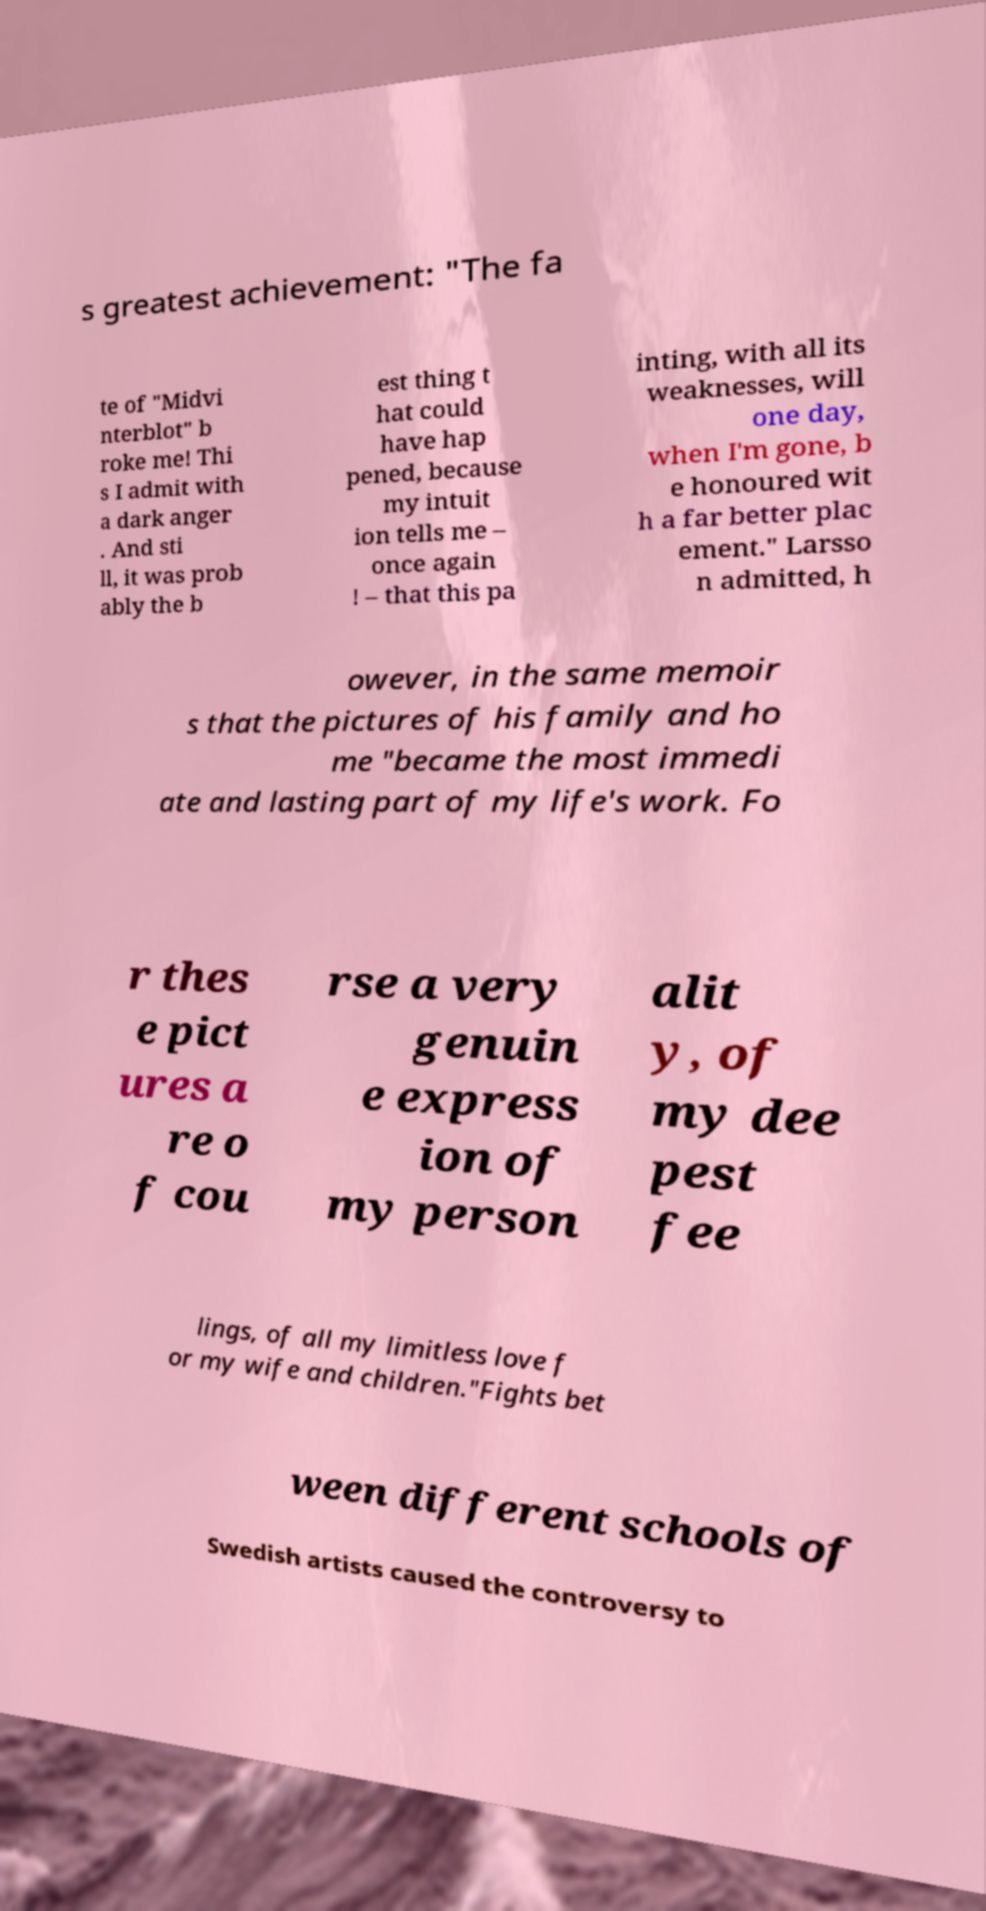Could you extract and type out the text from this image? s greatest achievement: "The fa te of "Midvi nterblot" b roke me! Thi s I admit with a dark anger . And sti ll, it was prob ably the b est thing t hat could have hap pened, because my intuit ion tells me – once again ! – that this pa inting, with all its weaknesses, will one day, when I'm gone, b e honoured wit h a far better plac ement." Larsso n admitted, h owever, in the same memoir s that the pictures of his family and ho me "became the most immedi ate and lasting part of my life's work. Fo r thes e pict ures a re o f cou rse a very genuin e express ion of my person alit y, of my dee pest fee lings, of all my limitless love f or my wife and children."Fights bet ween different schools of Swedish artists caused the controversy to 